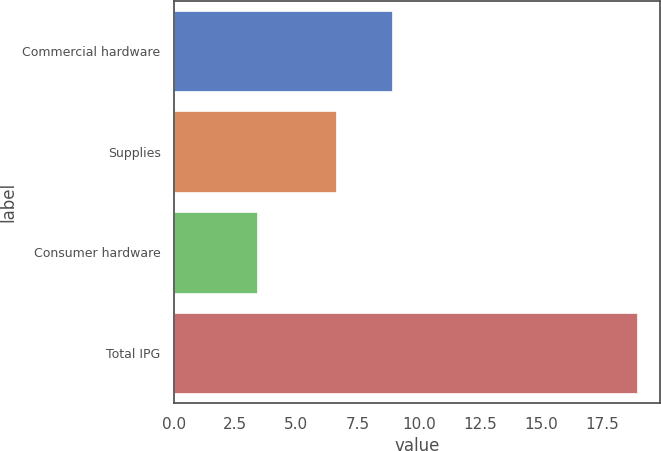<chart> <loc_0><loc_0><loc_500><loc_500><bar_chart><fcel>Commercial hardware<fcel>Supplies<fcel>Consumer hardware<fcel>Total IPG<nl><fcel>8.9<fcel>6.6<fcel>3.4<fcel>18.9<nl></chart> 